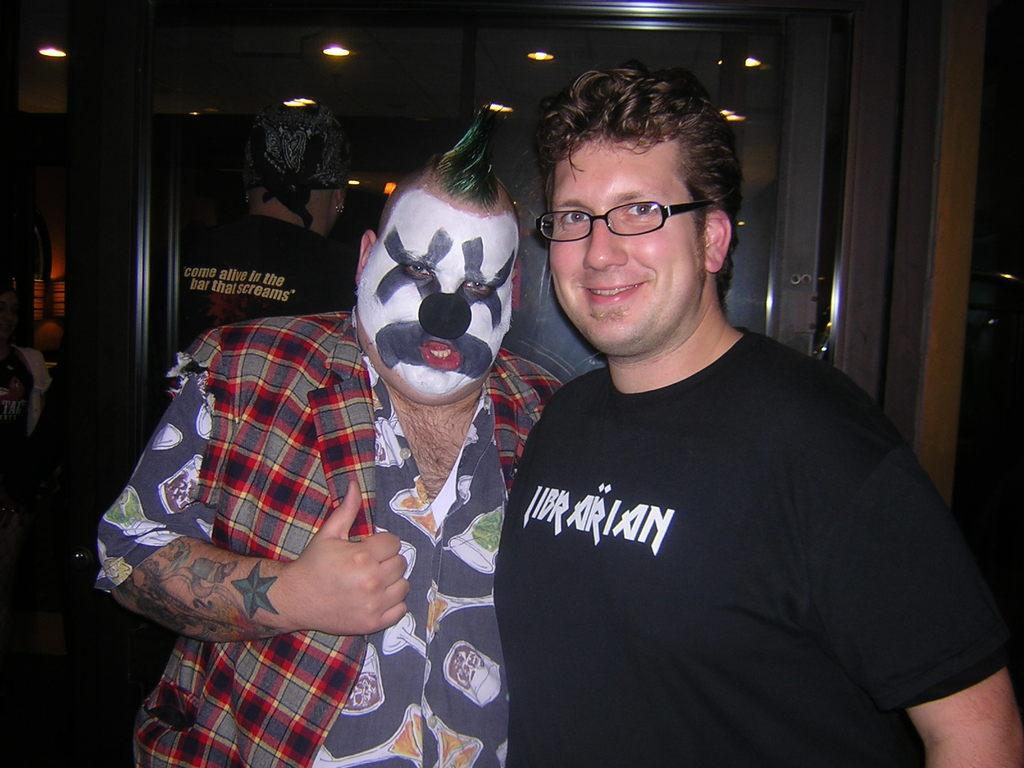How many people are present in the image? There are two people standing in the image. What is the facial expression of one of the men? One of the men is smiling. What color is the t-shirt worn by the man? The man is wearing a black t-shirt. What accessory is the man wearing? The man is wearing spectacles. What can be seen in the background of the image? There are lights and a board in the background of the image. How would you describe the lighting in the image? The background is dark. What type of dog is sitting next to the man in the image? There is no dog present in the image. What game are the two people playing in the image? There is no game visible in the image. What type of apparel is the man wearing on his feet? The provided facts do not mention the man's footwear. 